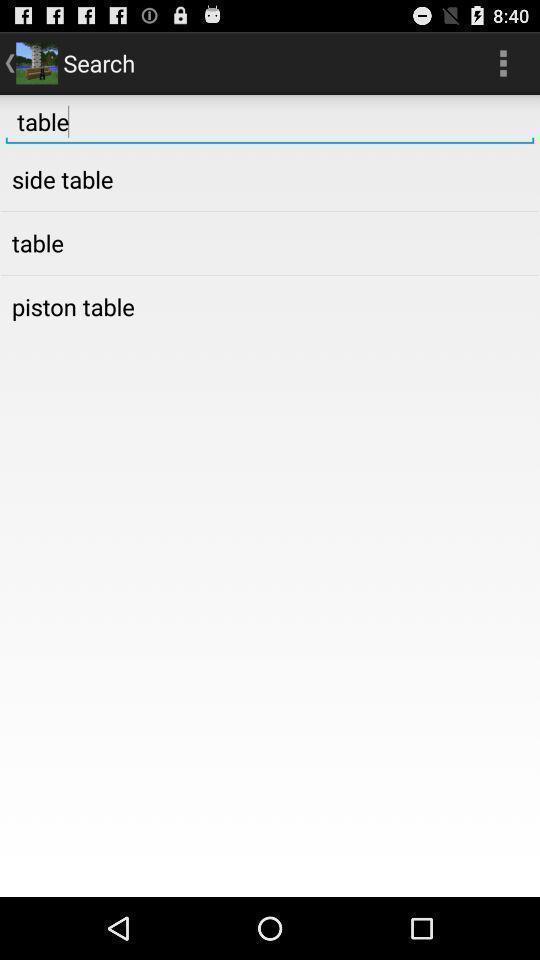Please provide a description for this image. Search page. 